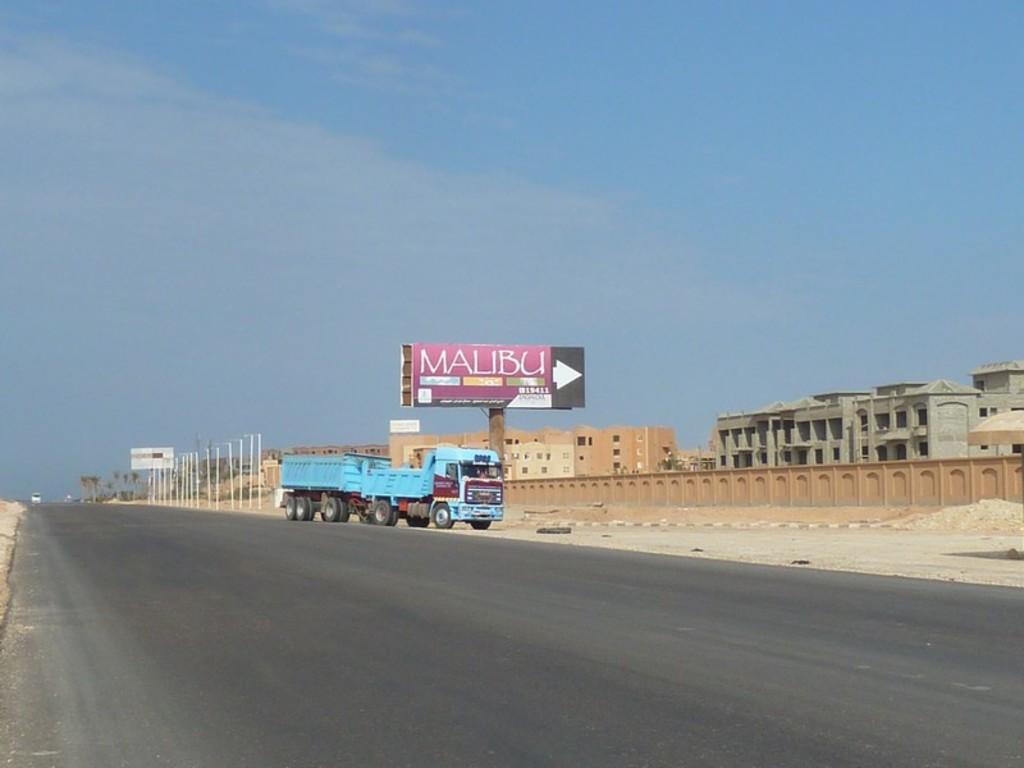What city is on the sign?
Your response must be concise. Malibu. 